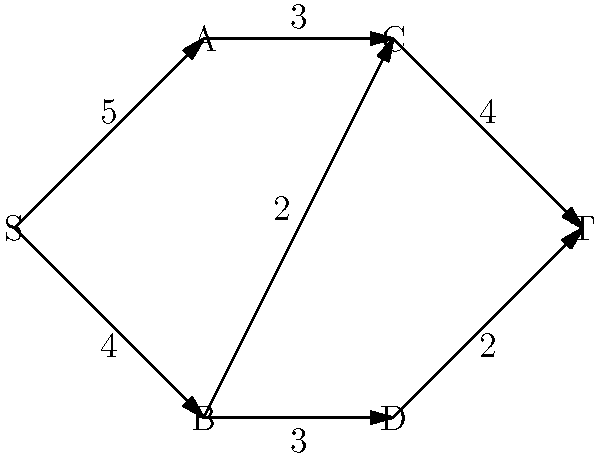In your role as a bereavement counselor, you've developed a network of coping strategies to help clients process their grief. The graph represents the flow of positive emotions through these strategies, where S is the starting point of grief, T is the target emotional state, and A, B, C, D are different coping mechanisms. The edge weights represent the maximum capacity of positive emotion flow between strategies. What is the maximum flow of positive emotions from S to T in this network? To solve this maximum flow problem, we can use the Ford-Fulkerson algorithm:

1. Initialize flow to 0 for all edges.

2. Find an augmenting path from S to T:
   Path 1: S -> A -> C -> T (min capacity: 3)
   Increase flow by 3
   Remaining capacities: S->A: 2, A->C: 0, C->T: 1

3. Find another augmenting path:
   Path 2: S -> B -> C -> T (min capacity: 2)
   Increase flow by 2
   Remaining capacities: S->B: 2, B->C: 0, C->T: 0

4. Find another augmenting path:
   Path 3: S -> B -> D -> T (min capacity: 2)
   Increase flow by 2
   Remaining capacities: S->B: 0, B->D: 1, D->T: 0

5. No more augmenting paths exist.

The maximum flow is the sum of all flow increases:
$3 + 2 + 2 = 7$

This result represents the maximum amount of positive emotional support that can flow through the network of coping strategies, helping clients move from their initial state of grief to a more positive emotional state.
Answer: 7 